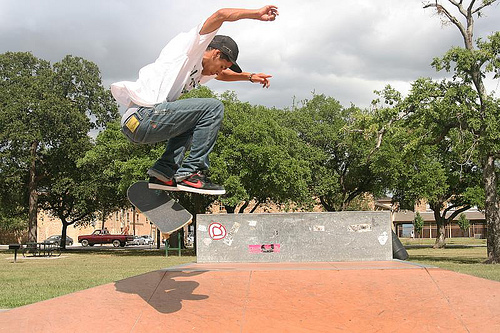<image>
Is the shadow in the ground? No. The shadow is not contained within the ground. These objects have a different spatial relationship. 